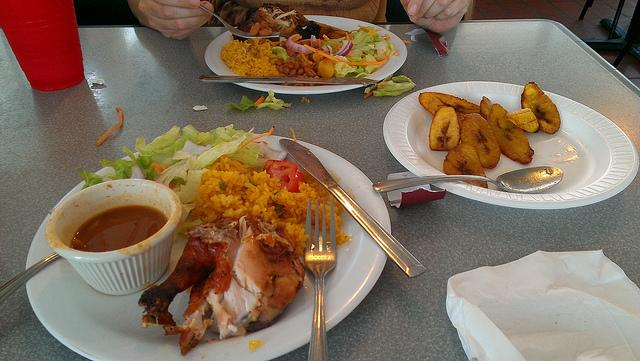What type of rice is on the dishes? Please explain your reasoning. spanish rice. It has been coked till golden brown. 